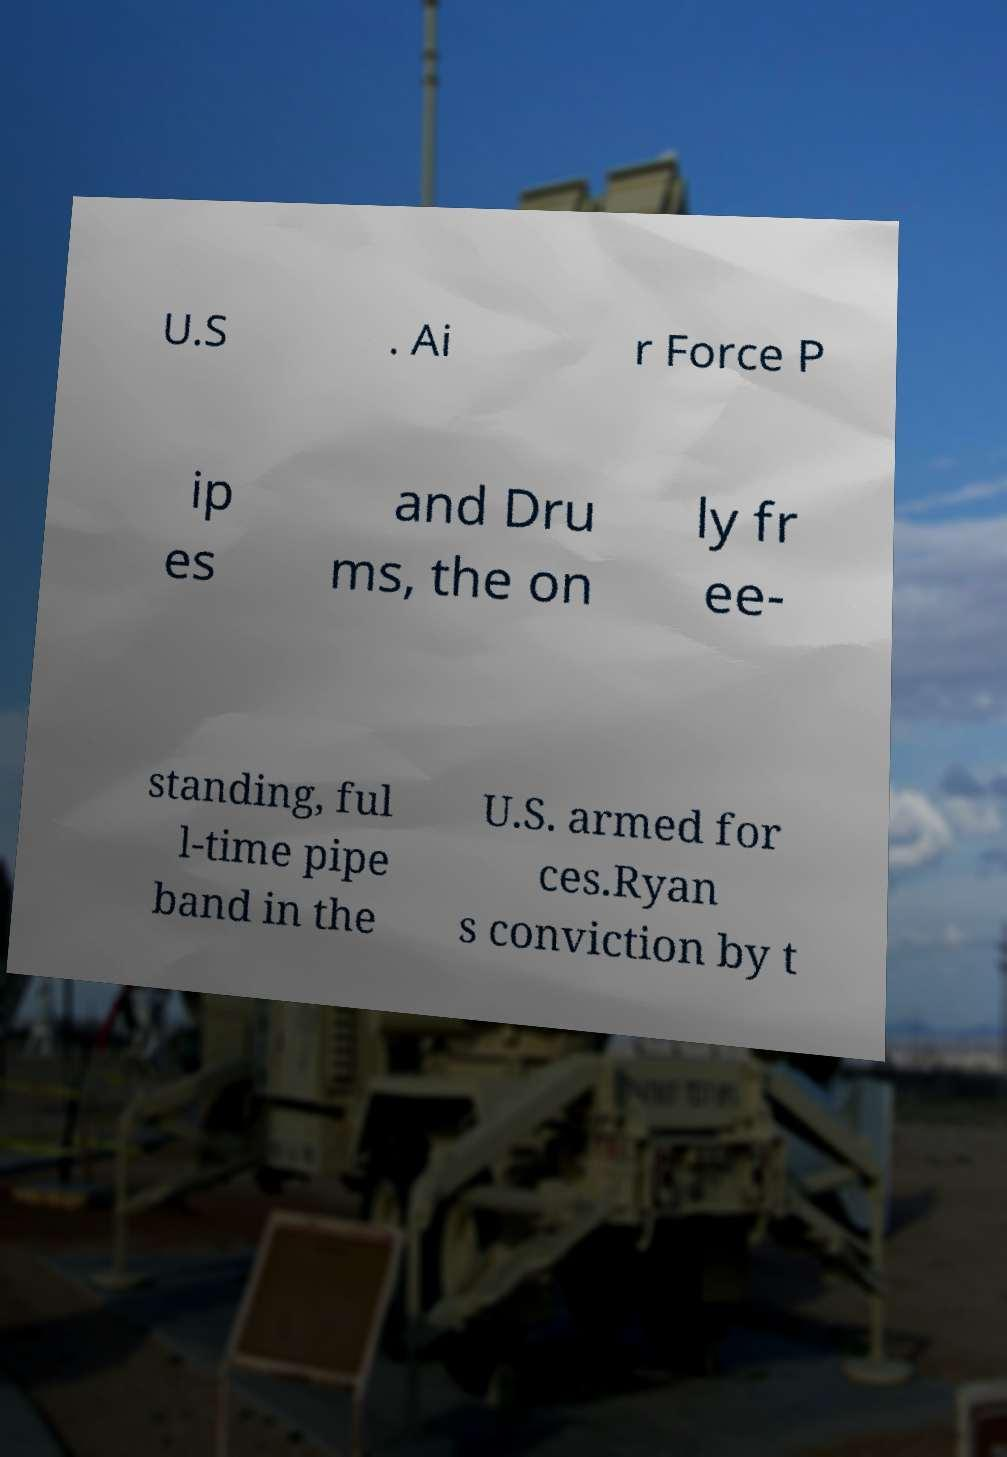There's text embedded in this image that I need extracted. Can you transcribe it verbatim? U.S . Ai r Force P ip es and Dru ms, the on ly fr ee- standing, ful l-time pipe band in the U.S. armed for ces.Ryan s conviction by t 